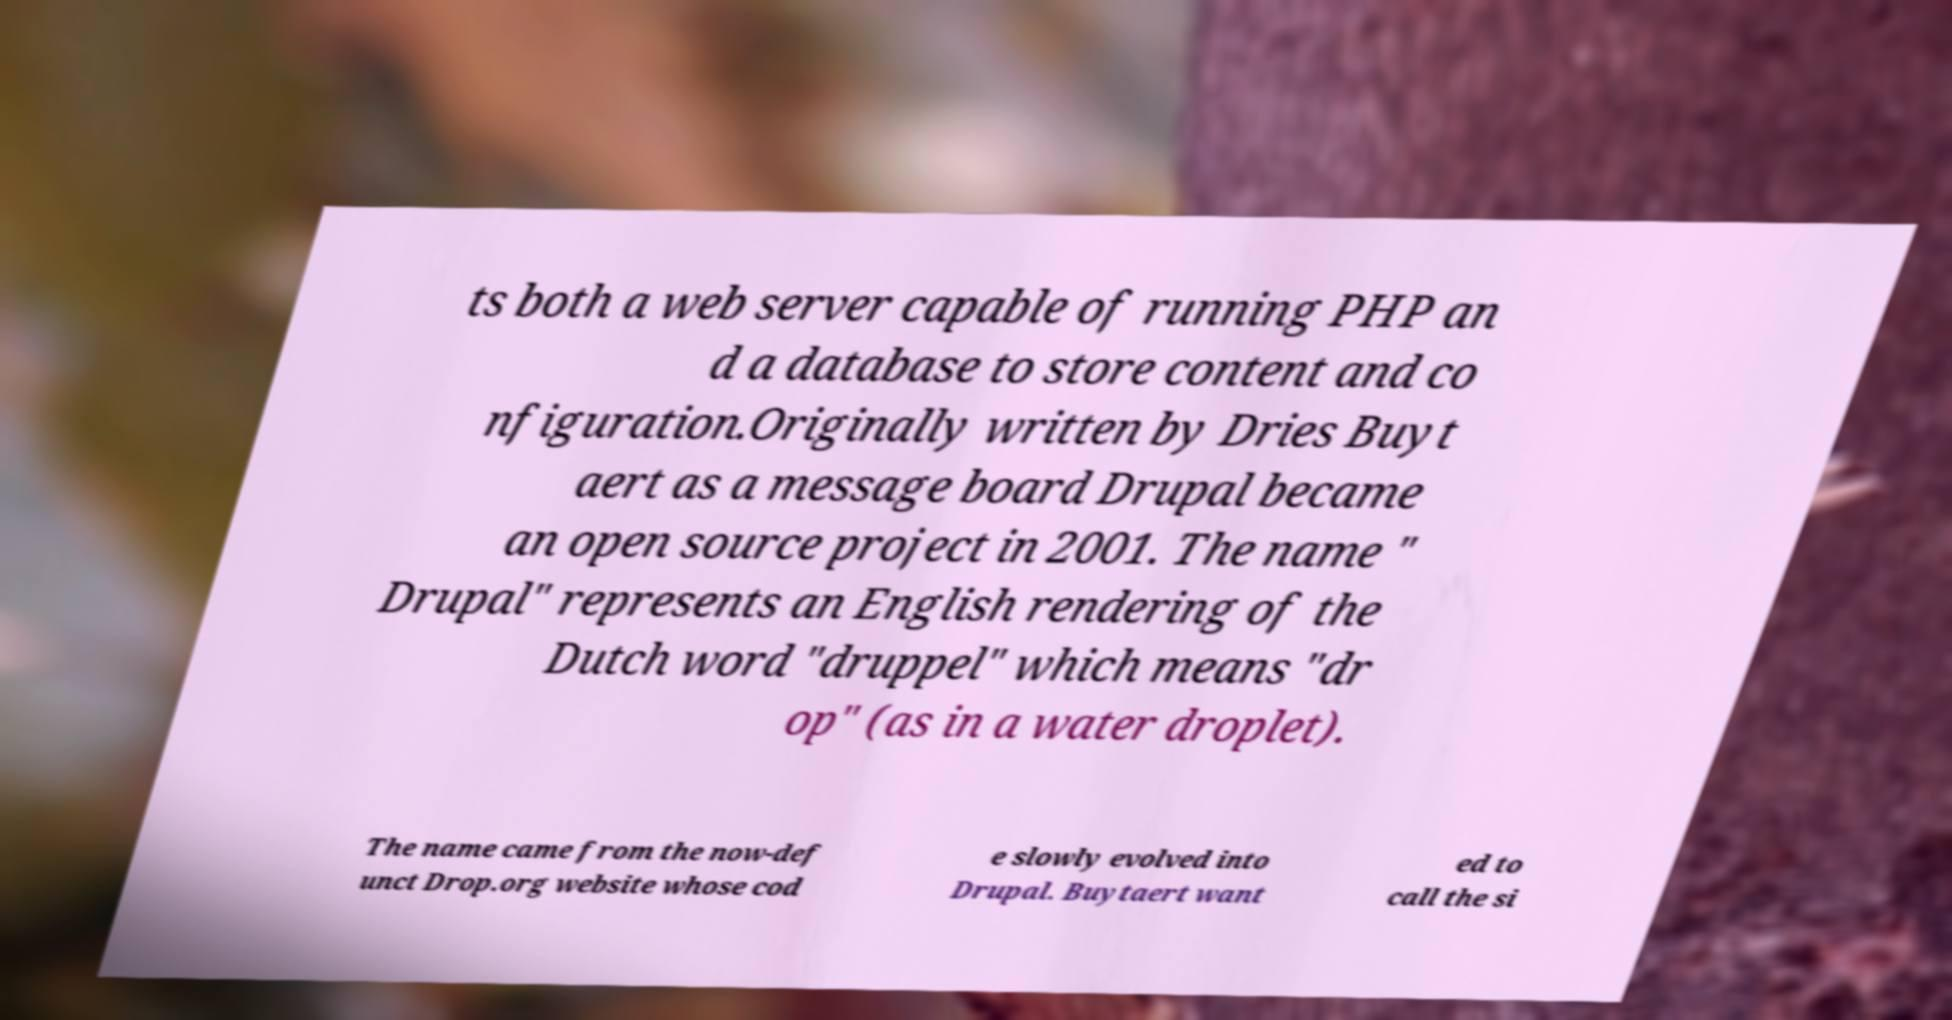Can you read and provide the text displayed in the image?This photo seems to have some interesting text. Can you extract and type it out for me? ts both a web server capable of running PHP an d a database to store content and co nfiguration.Originally written by Dries Buyt aert as a message board Drupal became an open source project in 2001. The name " Drupal" represents an English rendering of the Dutch word "druppel" which means "dr op" (as in a water droplet). The name came from the now-def unct Drop.org website whose cod e slowly evolved into Drupal. Buytaert want ed to call the si 